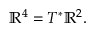Convert formula to latex. <formula><loc_0><loc_0><loc_500><loc_500>\mathbb { R } ^ { 4 } = T ^ { * } \mathbb { R } ^ { 2 } .</formula> 